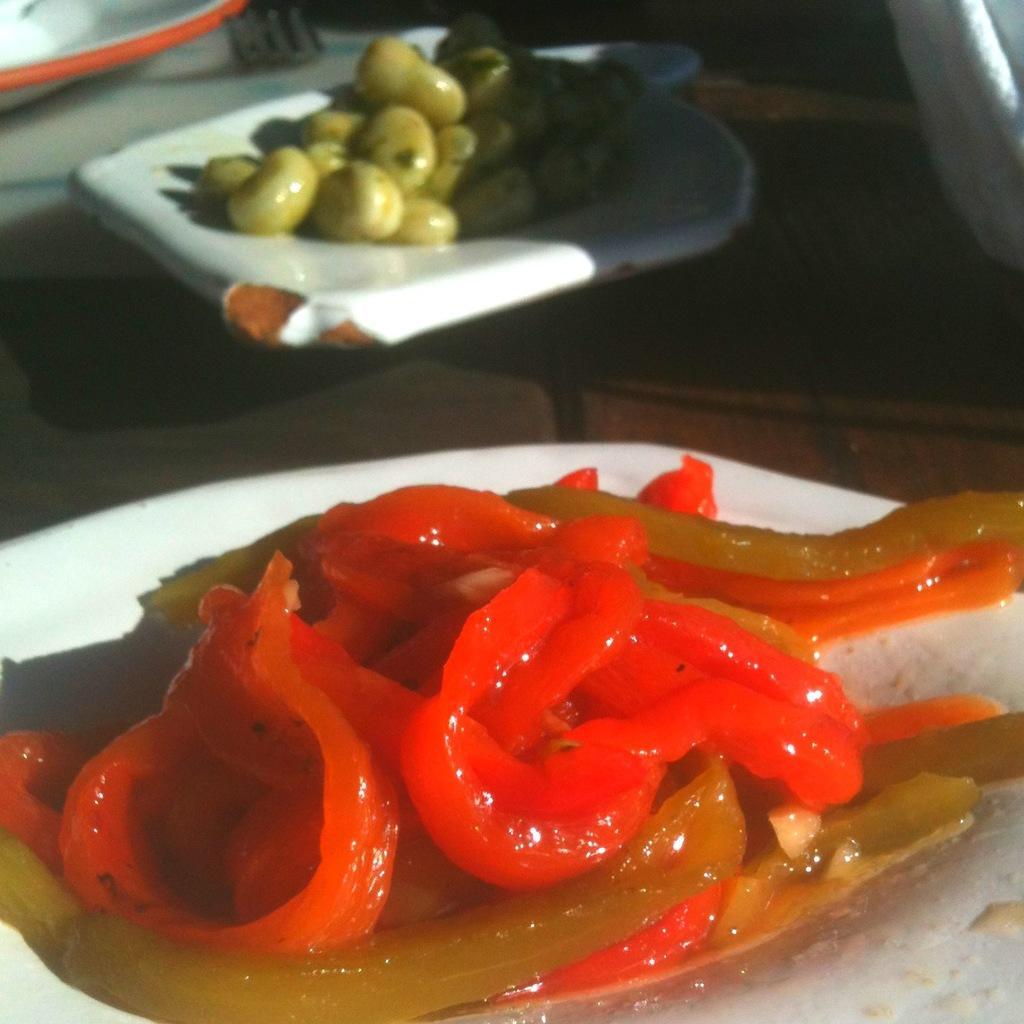Can you describe this image briefly? In this picture we can see some different types of food items are placed in one place. 